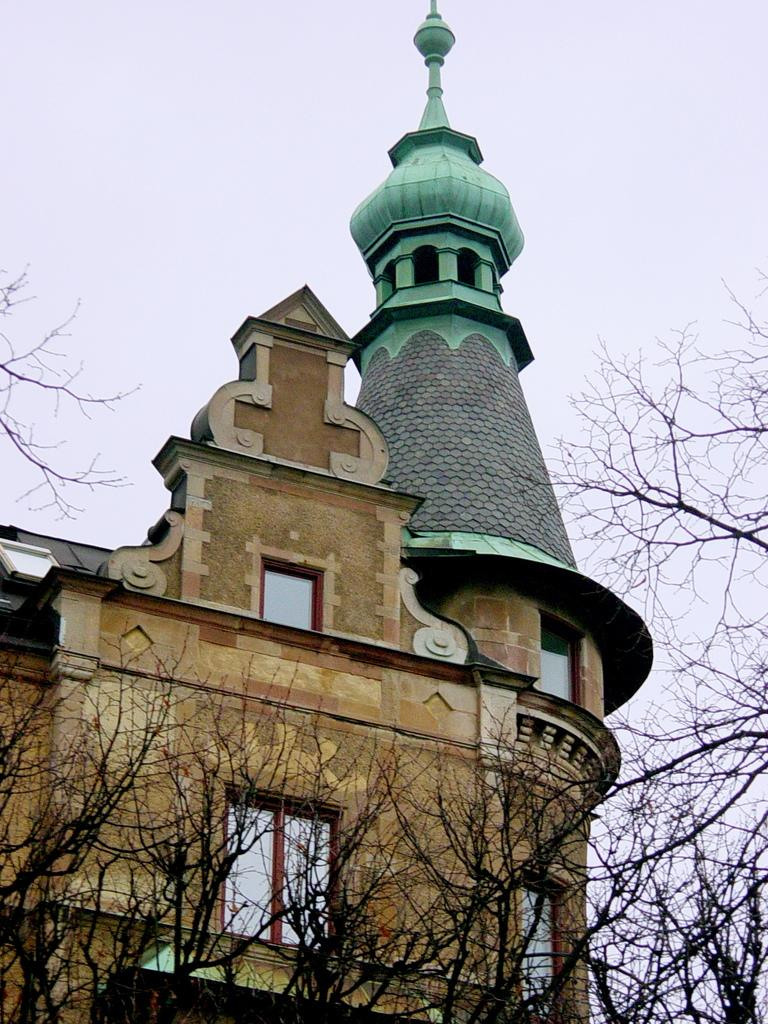What type of vegetation can be seen in the image? There are trees in the image. What structure is located behind the trees? There is a building behind the trees. What is visible at the top of the image? The sky is visible at the top of the image. What type of wine is being served at the concert in the image? There is no wine or concert present in the image; it features trees, a building, and the sky. Is there any popcorn visible in the image? There is no popcorn present in the image. 